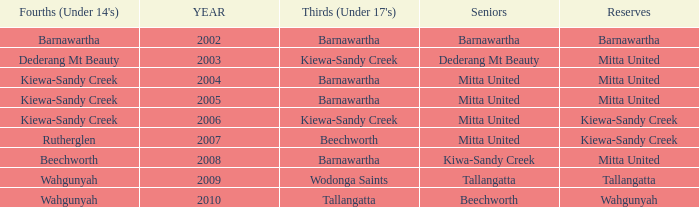Which Thirds (Under 17's) have a Reserve of barnawartha? Barnawartha. 